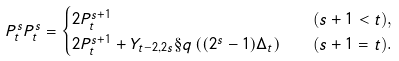Convert formula to latex. <formula><loc_0><loc_0><loc_500><loc_500>P _ { t } ^ { s } P _ { t } ^ { s } & = \begin{cases} 2 P _ { t } ^ { s + 1 } & \text {\quad($s+1<t$),} \\ 2 P _ { t } ^ { s + 1 } + Y _ { t - 2 , 2 s } \S q \left ( ( 2 ^ { s } - 1 ) \Delta _ { t } \right ) & \text {\quad($s+1 = t$).} \end{cases}</formula> 